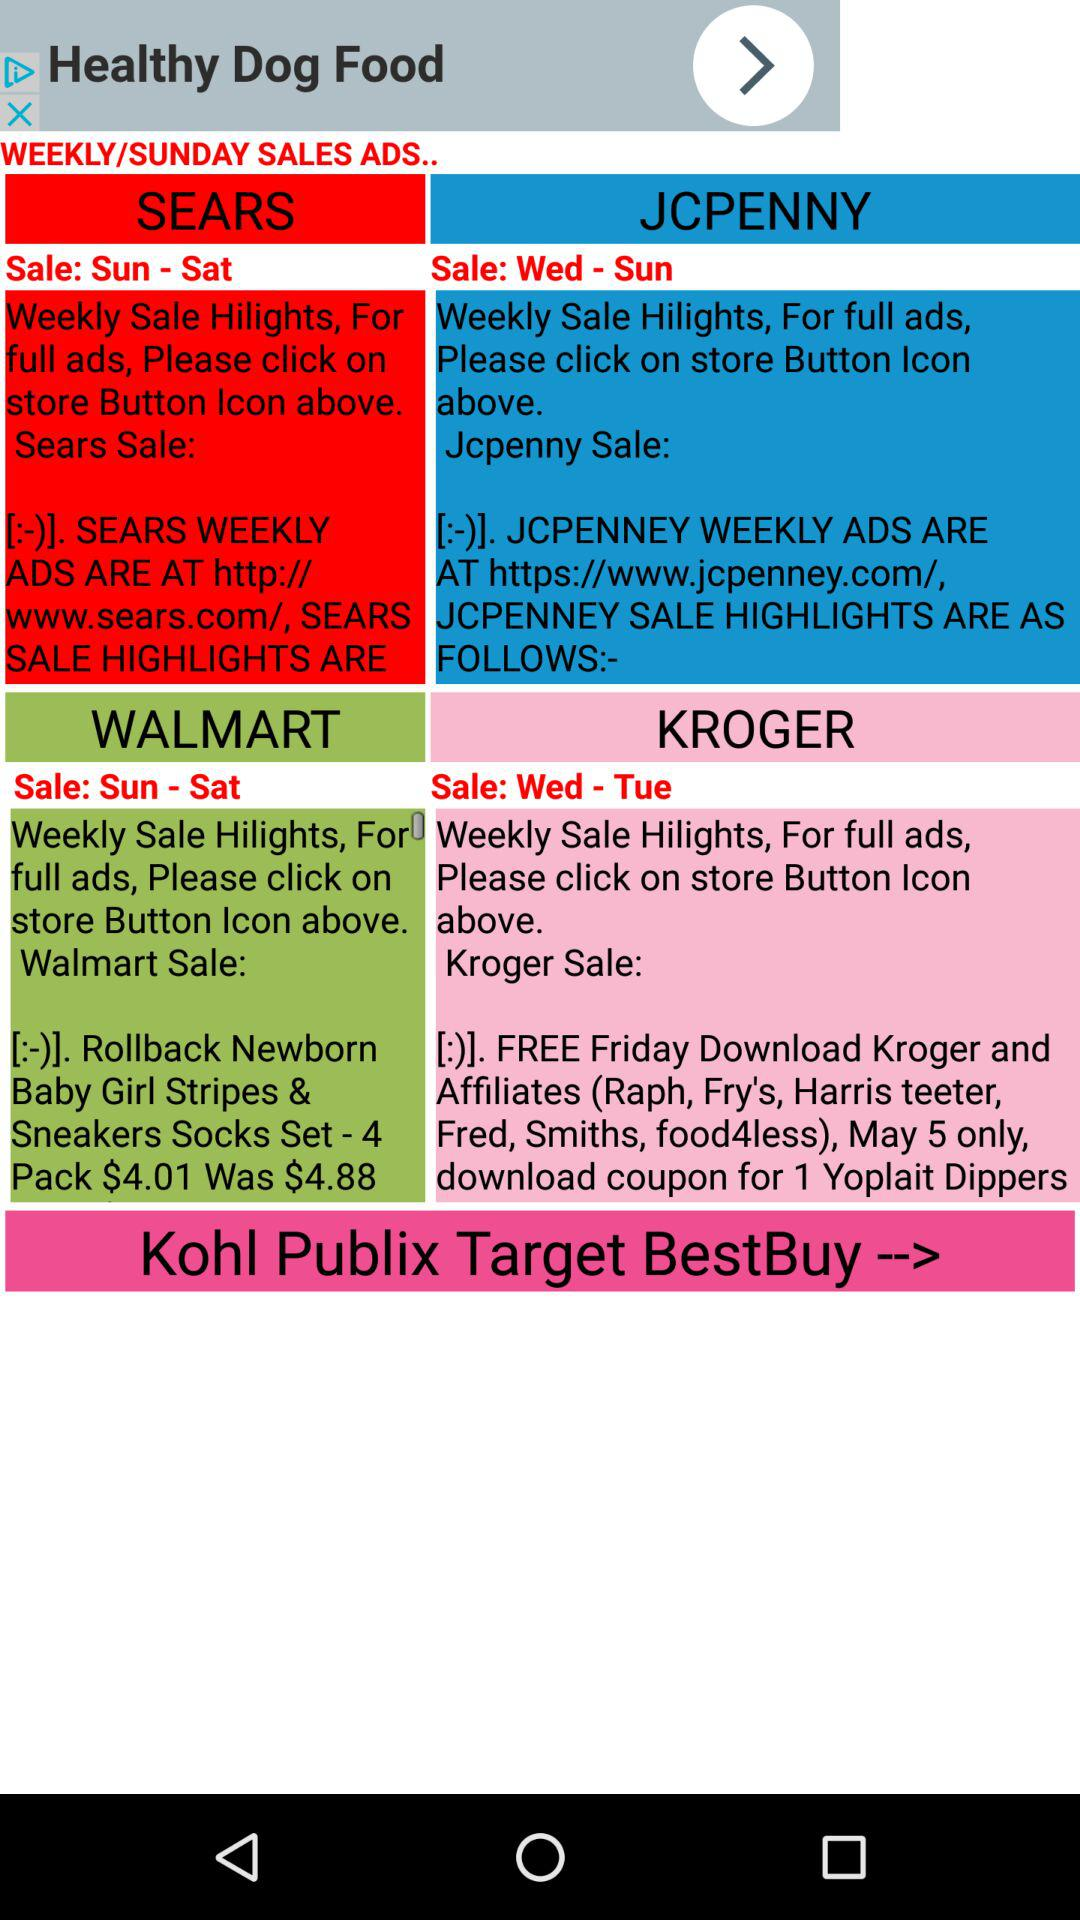What is the sale day of Walmart? The sale days of Walmart are from Sunday to Saturday. 